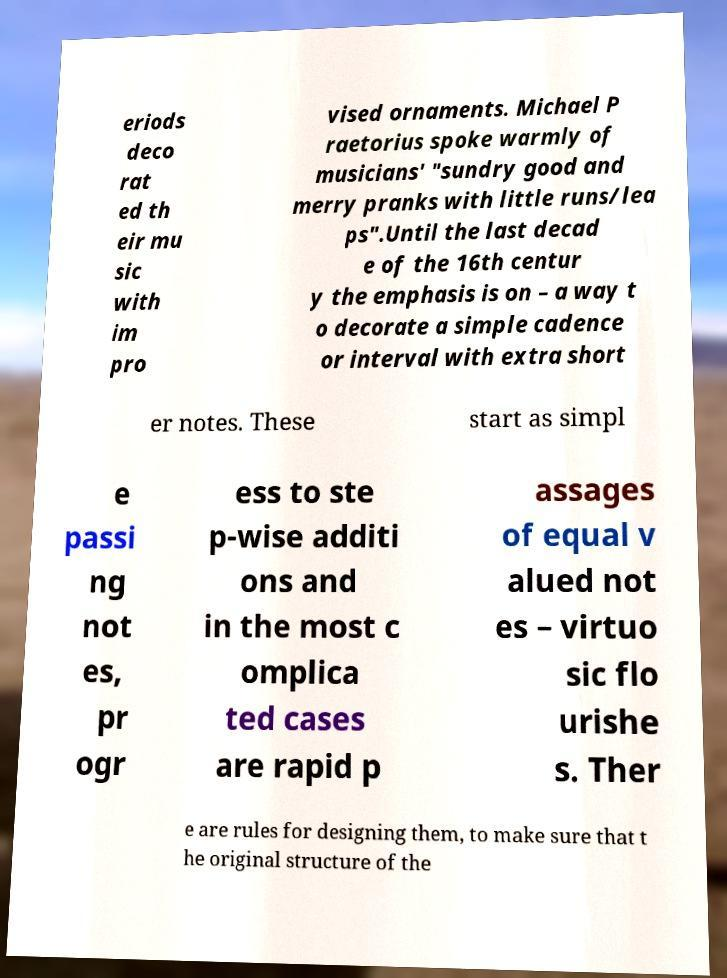Please read and relay the text visible in this image. What does it say? eriods deco rat ed th eir mu sic with im pro vised ornaments. Michael P raetorius spoke warmly of musicians' "sundry good and merry pranks with little runs/lea ps".Until the last decad e of the 16th centur y the emphasis is on – a way t o decorate a simple cadence or interval with extra short er notes. These start as simpl e passi ng not es, pr ogr ess to ste p-wise additi ons and in the most c omplica ted cases are rapid p assages of equal v alued not es – virtuo sic flo urishe s. Ther e are rules for designing them, to make sure that t he original structure of the 